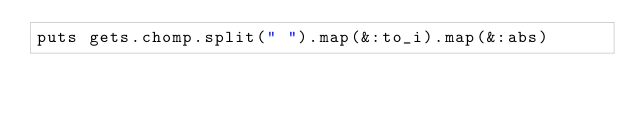<code> <loc_0><loc_0><loc_500><loc_500><_Ruby_>puts gets.chomp.split(" ").map(&:to_i).map(&:abs)</code> 